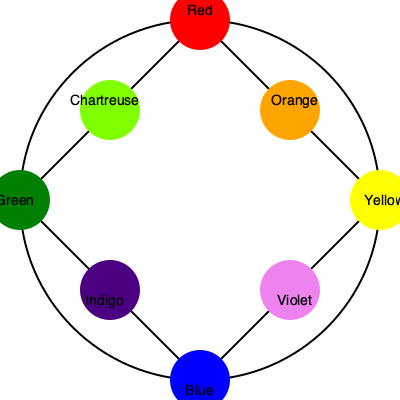In costume design, understanding color theory is crucial for creating visually balanced and harmonious outfits. Using the color wheel provided, which color would you choose to create a complementary color scheme with the color orange for a dramatic television scene? To determine the complementary color for orange, we need to follow these steps:

1. Locate orange on the color wheel (positioned between red and yellow).
2. Identify the color directly opposite orange on the wheel.
3. The color wheel is divided into primary, secondary, and tertiary colors:
   - Primary colors: Red, Yellow, Blue
   - Secondary colors: Orange, Green, Violet
   - Tertiary colors: Chartreuse, Indigo

4. Orange is a secondary color, so its complement will be a primary color.
5. Moving directly across the wheel from orange, we find blue.

In color theory, complementary colors are pairs of colors that are opposite each other on the color wheel. When used together, they create high contrast and visual interest, making them ideal for dramatic scenes in costume design.

For a television costume supervisor, using complementary colors like orange and blue can create a striking visual effect that stands out on screen, enhancing the dramatic impact of a scene.
Answer: Blue 